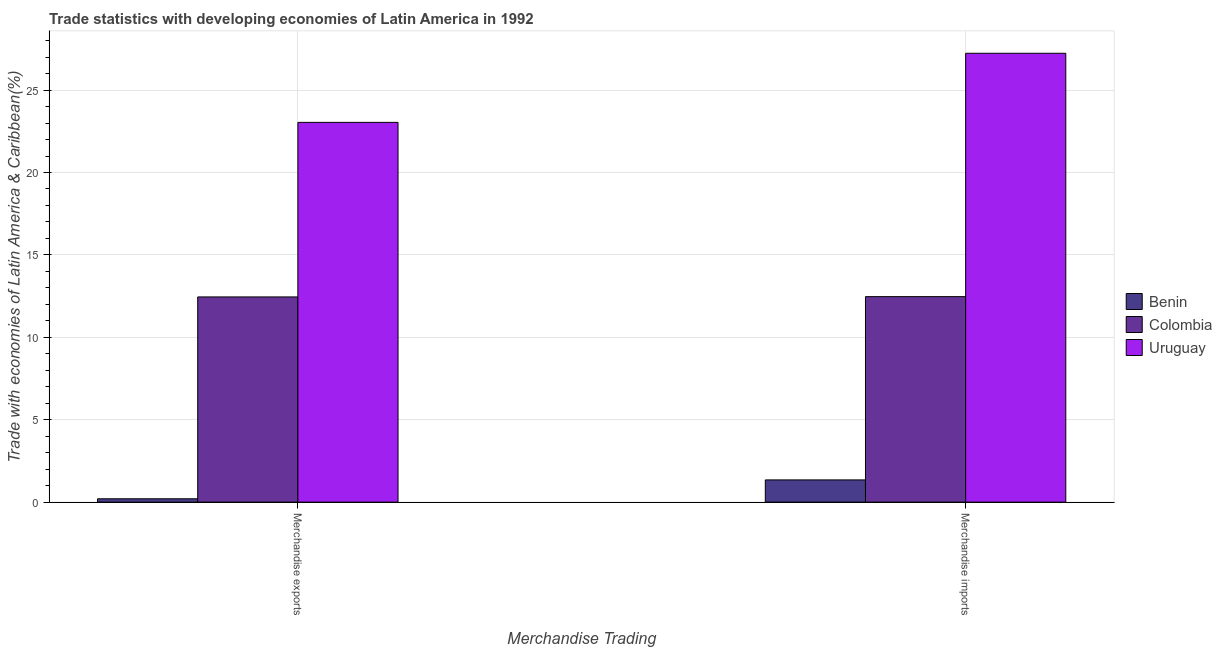How many different coloured bars are there?
Your response must be concise. 3. How many bars are there on the 1st tick from the left?
Provide a succinct answer. 3. How many bars are there on the 2nd tick from the right?
Make the answer very short. 3. What is the label of the 1st group of bars from the left?
Provide a short and direct response. Merchandise exports. What is the merchandise imports in Benin?
Your answer should be compact. 1.35. Across all countries, what is the maximum merchandise exports?
Your response must be concise. 23.04. Across all countries, what is the minimum merchandise exports?
Your answer should be compact. 0.2. In which country was the merchandise imports maximum?
Offer a terse response. Uruguay. In which country was the merchandise imports minimum?
Your response must be concise. Benin. What is the total merchandise imports in the graph?
Offer a very short reply. 41.05. What is the difference between the merchandise imports in Benin and that in Uruguay?
Give a very brief answer. -25.89. What is the difference between the merchandise exports in Colombia and the merchandise imports in Benin?
Your answer should be compact. 11.1. What is the average merchandise exports per country?
Provide a succinct answer. 11.9. What is the difference between the merchandise imports and merchandise exports in Uruguay?
Offer a terse response. 4.19. What is the ratio of the merchandise exports in Benin to that in Colombia?
Give a very brief answer. 0.02. In how many countries, is the merchandise exports greater than the average merchandise exports taken over all countries?
Offer a very short reply. 2. What does the 1st bar from the left in Merchandise imports represents?
Provide a short and direct response. Benin. What does the 2nd bar from the right in Merchandise imports represents?
Offer a terse response. Colombia. How many bars are there?
Your response must be concise. 6. How many countries are there in the graph?
Provide a short and direct response. 3. What is the difference between two consecutive major ticks on the Y-axis?
Ensure brevity in your answer.  5. Does the graph contain grids?
Provide a succinct answer. Yes. How are the legend labels stacked?
Make the answer very short. Vertical. What is the title of the graph?
Offer a very short reply. Trade statistics with developing economies of Latin America in 1992. Does "Seychelles" appear as one of the legend labels in the graph?
Ensure brevity in your answer.  No. What is the label or title of the X-axis?
Keep it short and to the point. Merchandise Trading. What is the label or title of the Y-axis?
Offer a terse response. Trade with economies of Latin America & Caribbean(%). What is the Trade with economies of Latin America & Caribbean(%) in Benin in Merchandise exports?
Keep it short and to the point. 0.2. What is the Trade with economies of Latin America & Caribbean(%) of Colombia in Merchandise exports?
Your answer should be compact. 12.45. What is the Trade with economies of Latin America & Caribbean(%) in Uruguay in Merchandise exports?
Offer a terse response. 23.04. What is the Trade with economies of Latin America & Caribbean(%) of Benin in Merchandise imports?
Provide a short and direct response. 1.35. What is the Trade with economies of Latin America & Caribbean(%) of Colombia in Merchandise imports?
Your response must be concise. 12.47. What is the Trade with economies of Latin America & Caribbean(%) in Uruguay in Merchandise imports?
Offer a terse response. 27.23. Across all Merchandise Trading, what is the maximum Trade with economies of Latin America & Caribbean(%) of Benin?
Your answer should be compact. 1.35. Across all Merchandise Trading, what is the maximum Trade with economies of Latin America & Caribbean(%) in Colombia?
Provide a short and direct response. 12.47. Across all Merchandise Trading, what is the maximum Trade with economies of Latin America & Caribbean(%) of Uruguay?
Your answer should be very brief. 27.23. Across all Merchandise Trading, what is the minimum Trade with economies of Latin America & Caribbean(%) of Benin?
Ensure brevity in your answer.  0.2. Across all Merchandise Trading, what is the minimum Trade with economies of Latin America & Caribbean(%) of Colombia?
Offer a very short reply. 12.45. Across all Merchandise Trading, what is the minimum Trade with economies of Latin America & Caribbean(%) of Uruguay?
Offer a very short reply. 23.04. What is the total Trade with economies of Latin America & Caribbean(%) of Benin in the graph?
Provide a succinct answer. 1.55. What is the total Trade with economies of Latin America & Caribbean(%) in Colombia in the graph?
Offer a terse response. 24.92. What is the total Trade with economies of Latin America & Caribbean(%) in Uruguay in the graph?
Ensure brevity in your answer.  50.27. What is the difference between the Trade with economies of Latin America & Caribbean(%) of Benin in Merchandise exports and that in Merchandise imports?
Provide a succinct answer. -1.15. What is the difference between the Trade with economies of Latin America & Caribbean(%) of Colombia in Merchandise exports and that in Merchandise imports?
Ensure brevity in your answer.  -0.02. What is the difference between the Trade with economies of Latin America & Caribbean(%) in Uruguay in Merchandise exports and that in Merchandise imports?
Your answer should be very brief. -4.19. What is the difference between the Trade with economies of Latin America & Caribbean(%) in Benin in Merchandise exports and the Trade with economies of Latin America & Caribbean(%) in Colombia in Merchandise imports?
Ensure brevity in your answer.  -12.26. What is the difference between the Trade with economies of Latin America & Caribbean(%) in Benin in Merchandise exports and the Trade with economies of Latin America & Caribbean(%) in Uruguay in Merchandise imports?
Your answer should be very brief. -27.03. What is the difference between the Trade with economies of Latin America & Caribbean(%) in Colombia in Merchandise exports and the Trade with economies of Latin America & Caribbean(%) in Uruguay in Merchandise imports?
Provide a short and direct response. -14.78. What is the average Trade with economies of Latin America & Caribbean(%) of Benin per Merchandise Trading?
Provide a short and direct response. 0.78. What is the average Trade with economies of Latin America & Caribbean(%) in Colombia per Merchandise Trading?
Make the answer very short. 12.46. What is the average Trade with economies of Latin America & Caribbean(%) of Uruguay per Merchandise Trading?
Offer a very short reply. 25.14. What is the difference between the Trade with economies of Latin America & Caribbean(%) in Benin and Trade with economies of Latin America & Caribbean(%) in Colombia in Merchandise exports?
Offer a terse response. -12.25. What is the difference between the Trade with economies of Latin America & Caribbean(%) of Benin and Trade with economies of Latin America & Caribbean(%) of Uruguay in Merchandise exports?
Your response must be concise. -22.84. What is the difference between the Trade with economies of Latin America & Caribbean(%) in Colombia and Trade with economies of Latin America & Caribbean(%) in Uruguay in Merchandise exports?
Your answer should be compact. -10.59. What is the difference between the Trade with economies of Latin America & Caribbean(%) in Benin and Trade with economies of Latin America & Caribbean(%) in Colombia in Merchandise imports?
Your response must be concise. -11.12. What is the difference between the Trade with economies of Latin America & Caribbean(%) in Benin and Trade with economies of Latin America & Caribbean(%) in Uruguay in Merchandise imports?
Offer a terse response. -25.89. What is the difference between the Trade with economies of Latin America & Caribbean(%) in Colombia and Trade with economies of Latin America & Caribbean(%) in Uruguay in Merchandise imports?
Your answer should be compact. -14.77. What is the ratio of the Trade with economies of Latin America & Caribbean(%) in Benin in Merchandise exports to that in Merchandise imports?
Provide a succinct answer. 0.15. What is the ratio of the Trade with economies of Latin America & Caribbean(%) of Colombia in Merchandise exports to that in Merchandise imports?
Provide a short and direct response. 1. What is the ratio of the Trade with economies of Latin America & Caribbean(%) in Uruguay in Merchandise exports to that in Merchandise imports?
Keep it short and to the point. 0.85. What is the difference between the highest and the second highest Trade with economies of Latin America & Caribbean(%) of Benin?
Offer a terse response. 1.15. What is the difference between the highest and the second highest Trade with economies of Latin America & Caribbean(%) in Colombia?
Your response must be concise. 0.02. What is the difference between the highest and the second highest Trade with economies of Latin America & Caribbean(%) in Uruguay?
Provide a succinct answer. 4.19. What is the difference between the highest and the lowest Trade with economies of Latin America & Caribbean(%) of Benin?
Give a very brief answer. 1.15. What is the difference between the highest and the lowest Trade with economies of Latin America & Caribbean(%) of Colombia?
Your answer should be very brief. 0.02. What is the difference between the highest and the lowest Trade with economies of Latin America & Caribbean(%) in Uruguay?
Ensure brevity in your answer.  4.19. 